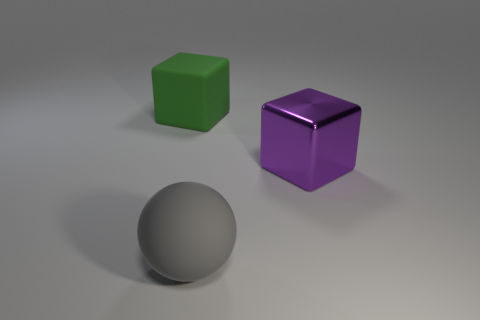There is a rubber object behind the metal object; is it the same shape as the object right of the big gray ball?
Ensure brevity in your answer.  Yes. There is a object that is in front of the green cube and behind the big gray thing; what is its shape?
Keep it short and to the point. Cube. There is a cube that is the same material as the ball; what is its size?
Ensure brevity in your answer.  Large. Is the number of big objects less than the number of big red shiny objects?
Provide a short and direct response. No. What material is the object that is to the right of the thing in front of the big object on the right side of the rubber sphere made of?
Your answer should be very brief. Metal. Do the big thing that is on the right side of the gray sphere and the cube that is to the left of the big gray sphere have the same material?
Offer a very short reply. No. What size is the thing that is both right of the big green cube and to the left of the shiny block?
Your answer should be compact. Large. There is a gray object that is the same size as the green matte cube; what is it made of?
Your answer should be very brief. Rubber. There is a matte thing that is behind the thing in front of the metallic cube; how many big green rubber things are in front of it?
Offer a very short reply. 0. Does the big cube on the left side of the gray rubber ball have the same color as the thing to the right of the rubber ball?
Keep it short and to the point. No. 